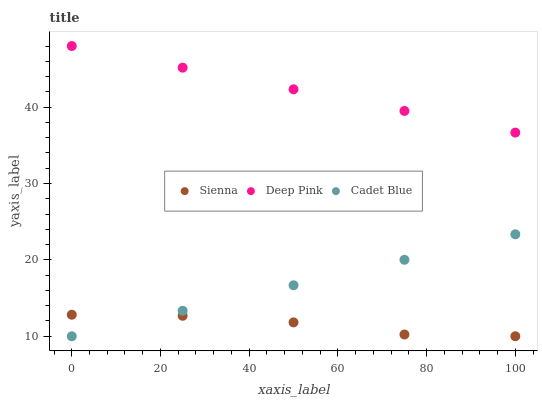Does Sienna have the minimum area under the curve?
Answer yes or no. Yes. Does Deep Pink have the maximum area under the curve?
Answer yes or no. Yes. Does Cadet Blue have the minimum area under the curve?
Answer yes or no. No. Does Cadet Blue have the maximum area under the curve?
Answer yes or no. No. Is Cadet Blue the smoothest?
Answer yes or no. Yes. Is Sienna the roughest?
Answer yes or no. Yes. Is Deep Pink the smoothest?
Answer yes or no. No. Is Deep Pink the roughest?
Answer yes or no. No. Does Sienna have the lowest value?
Answer yes or no. Yes. Does Deep Pink have the lowest value?
Answer yes or no. No. Does Deep Pink have the highest value?
Answer yes or no. Yes. Does Cadet Blue have the highest value?
Answer yes or no. No. Is Sienna less than Deep Pink?
Answer yes or no. Yes. Is Deep Pink greater than Cadet Blue?
Answer yes or no. Yes. Does Cadet Blue intersect Sienna?
Answer yes or no. Yes. Is Cadet Blue less than Sienna?
Answer yes or no. No. Is Cadet Blue greater than Sienna?
Answer yes or no. No. Does Sienna intersect Deep Pink?
Answer yes or no. No. 